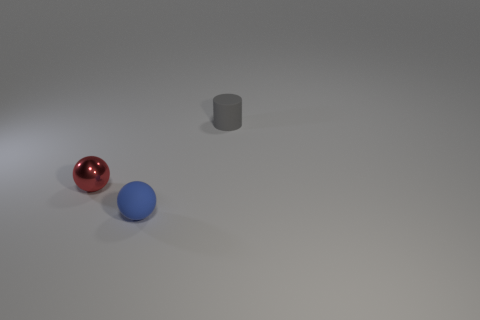Add 1 small red cylinders. How many objects exist? 4 Subtract all cylinders. How many objects are left? 2 Subtract all red matte spheres. Subtract all tiny red shiny things. How many objects are left? 2 Add 3 metallic spheres. How many metallic spheres are left? 4 Add 2 brown rubber objects. How many brown rubber objects exist? 2 Subtract 0 blue cylinders. How many objects are left? 3 